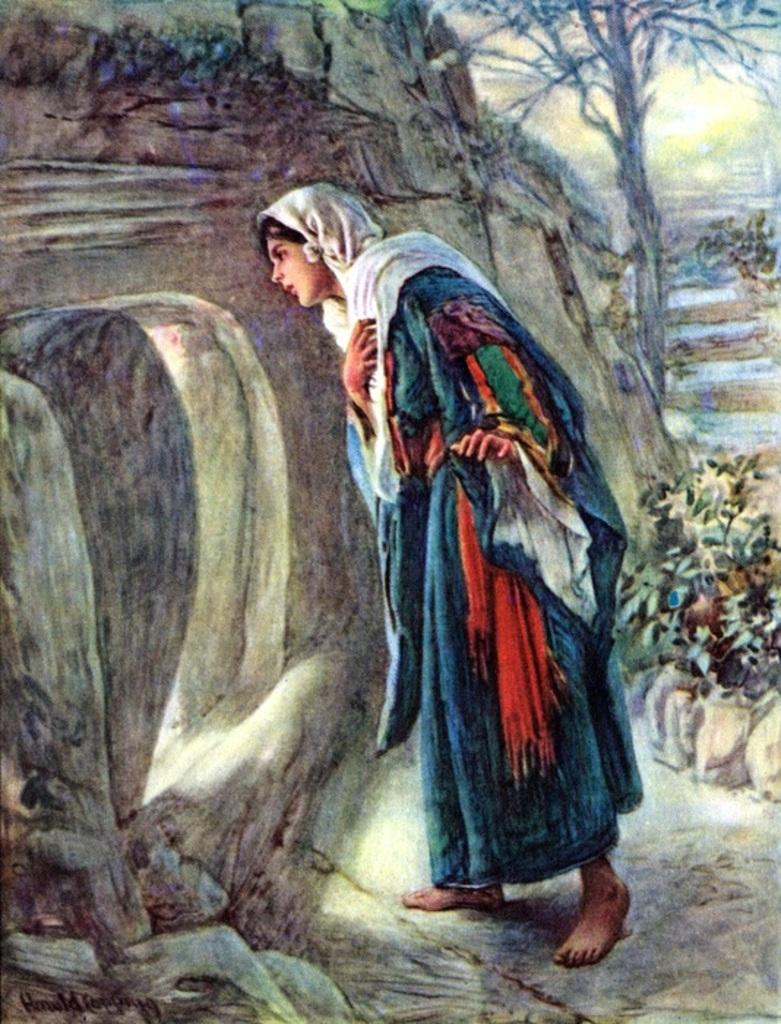What is the main subject of the image? The main subject of the image is a painting. What elements are present in the painting? The painting contains a person, a tree, plants, and rocks. Where is the text located in the image? The text is in the bottom left side of the image. How many women are depicted in the painting? There is no mention of women in the provided facts, so we cannot determine the number of women in the painting. Is there an owl visible in the painting? There is no mention of an owl in the provided facts, so we cannot determine if there is an owl in the painting. 